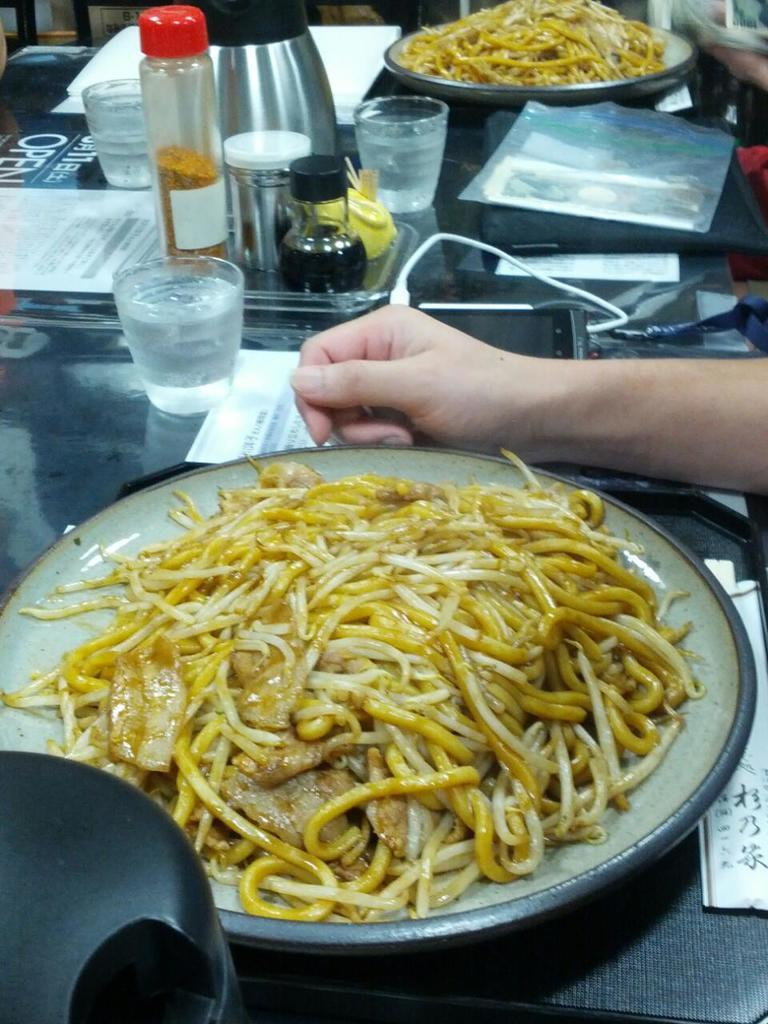What type of furniture is present in the image? There is a table in the image. What food item can be seen on the table? There are noodles on the table. Are there any other dishes or utensils on the table? Yes, there is a plate and a glass on the table. Is there any beverage container on the table? Yes, there is a bottle on the table. Can you tell me how many nuts are on the sidewalk in the image? There are no nuts or sidewalks present in the image; it features a table with noodles, a plate, a glass, and a bottle. Is there a kitty playing with the bottle on the table in the image? There is no kitty present in the image; it only shows a table with noodles, a plate, a glass, and a bottle. 